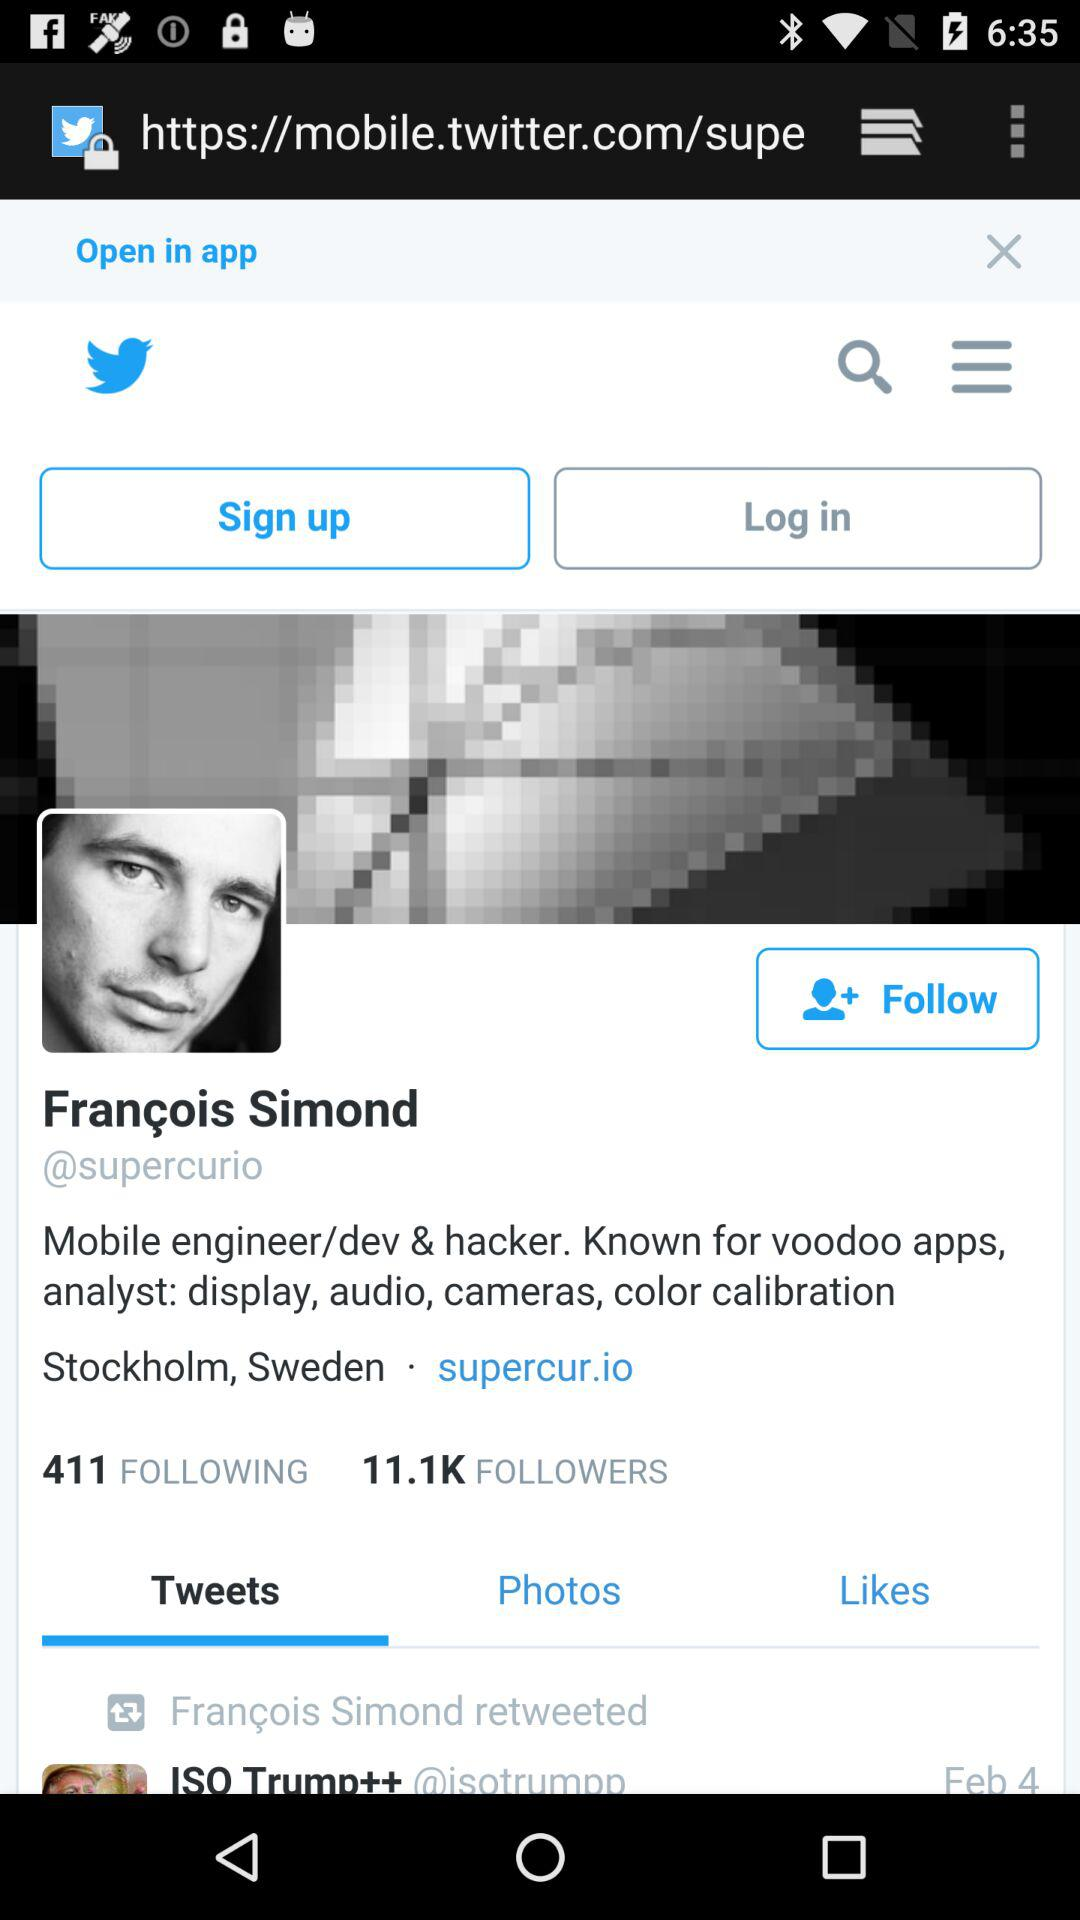How many followers does the person have? The person has 11.1K followers. 